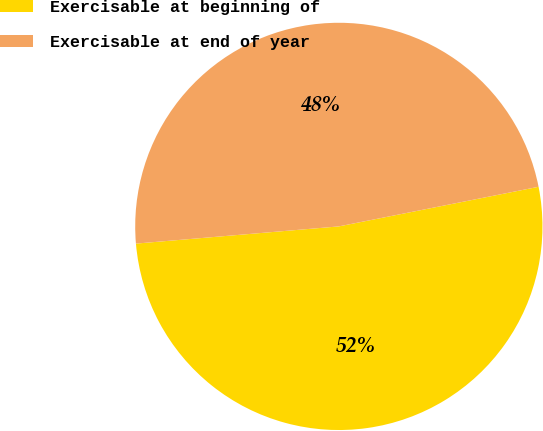Convert chart. <chart><loc_0><loc_0><loc_500><loc_500><pie_chart><fcel>Exercisable at beginning of<fcel>Exercisable at end of year<nl><fcel>51.77%<fcel>48.23%<nl></chart> 